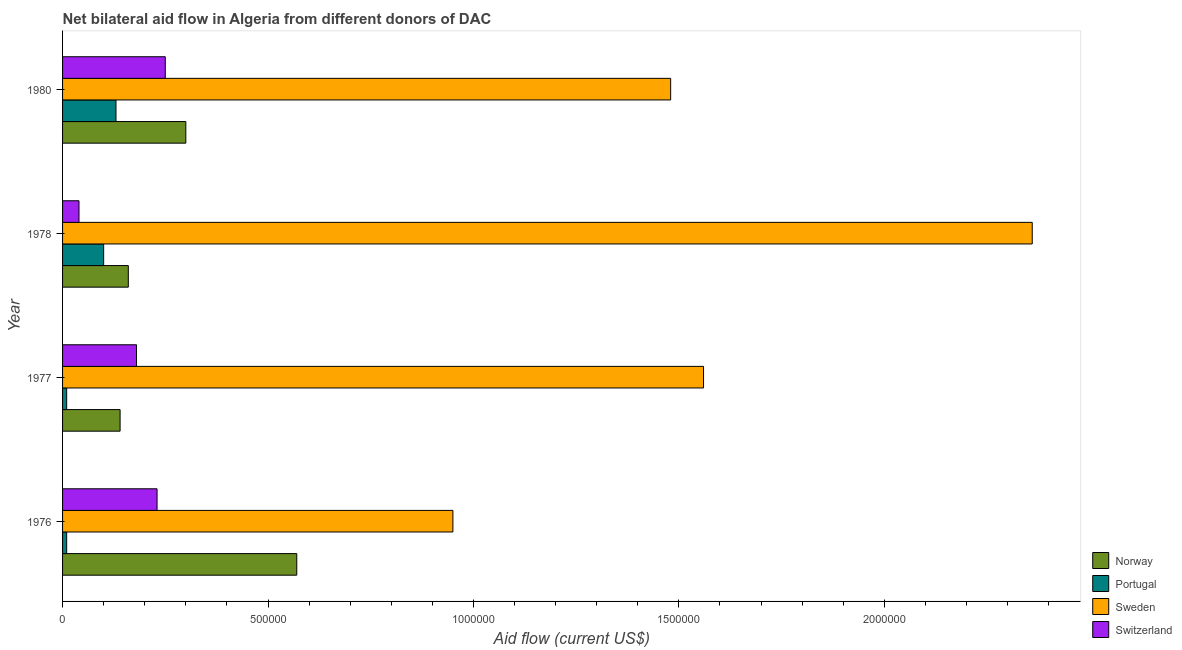How many different coloured bars are there?
Your response must be concise. 4. How many groups of bars are there?
Provide a succinct answer. 4. Are the number of bars on each tick of the Y-axis equal?
Offer a terse response. Yes. How many bars are there on the 4th tick from the bottom?
Ensure brevity in your answer.  4. What is the label of the 1st group of bars from the top?
Your response must be concise. 1980. What is the amount of aid given by norway in 1978?
Keep it short and to the point. 1.60e+05. Across all years, what is the maximum amount of aid given by portugal?
Provide a short and direct response. 1.30e+05. Across all years, what is the minimum amount of aid given by portugal?
Your response must be concise. 10000. In which year was the amount of aid given by switzerland maximum?
Your answer should be very brief. 1980. In which year was the amount of aid given by portugal minimum?
Ensure brevity in your answer.  1976. What is the total amount of aid given by portugal in the graph?
Your answer should be very brief. 2.50e+05. What is the difference between the amount of aid given by sweden in 1976 and that in 1980?
Offer a very short reply. -5.30e+05. What is the difference between the amount of aid given by switzerland in 1977 and the amount of aid given by sweden in 1976?
Your response must be concise. -7.70e+05. What is the average amount of aid given by sweden per year?
Provide a short and direct response. 1.59e+06. In the year 1978, what is the difference between the amount of aid given by sweden and amount of aid given by switzerland?
Your answer should be compact. 2.32e+06. In how many years, is the amount of aid given by norway greater than 1200000 US$?
Provide a succinct answer. 0. What is the ratio of the amount of aid given by portugal in 1976 to that in 1977?
Your answer should be very brief. 1. Is the difference between the amount of aid given by switzerland in 1976 and 1980 greater than the difference between the amount of aid given by sweden in 1976 and 1980?
Your answer should be compact. Yes. What is the difference between the highest and the second highest amount of aid given by norway?
Provide a short and direct response. 2.70e+05. What is the difference between the highest and the lowest amount of aid given by switzerland?
Ensure brevity in your answer.  2.10e+05. What does the 4th bar from the top in 1980 represents?
Give a very brief answer. Norway. What does the 2nd bar from the bottom in 1977 represents?
Offer a terse response. Portugal. How many years are there in the graph?
Make the answer very short. 4. Does the graph contain any zero values?
Provide a succinct answer. No. Does the graph contain grids?
Give a very brief answer. No. How many legend labels are there?
Give a very brief answer. 4. How are the legend labels stacked?
Your response must be concise. Vertical. What is the title of the graph?
Your response must be concise. Net bilateral aid flow in Algeria from different donors of DAC. Does "Social Insurance" appear as one of the legend labels in the graph?
Provide a short and direct response. No. What is the Aid flow (current US$) in Norway in 1976?
Provide a short and direct response. 5.70e+05. What is the Aid flow (current US$) in Sweden in 1976?
Your answer should be very brief. 9.50e+05. What is the Aid flow (current US$) in Switzerland in 1976?
Keep it short and to the point. 2.30e+05. What is the Aid flow (current US$) of Norway in 1977?
Keep it short and to the point. 1.40e+05. What is the Aid flow (current US$) of Portugal in 1977?
Provide a short and direct response. 10000. What is the Aid flow (current US$) of Sweden in 1977?
Keep it short and to the point. 1.56e+06. What is the Aid flow (current US$) in Switzerland in 1977?
Your answer should be very brief. 1.80e+05. What is the Aid flow (current US$) in Portugal in 1978?
Ensure brevity in your answer.  1.00e+05. What is the Aid flow (current US$) of Sweden in 1978?
Offer a very short reply. 2.36e+06. What is the Aid flow (current US$) in Switzerland in 1978?
Provide a succinct answer. 4.00e+04. What is the Aid flow (current US$) of Sweden in 1980?
Offer a terse response. 1.48e+06. What is the Aid flow (current US$) of Switzerland in 1980?
Keep it short and to the point. 2.50e+05. Across all years, what is the maximum Aid flow (current US$) in Norway?
Provide a succinct answer. 5.70e+05. Across all years, what is the maximum Aid flow (current US$) in Portugal?
Offer a very short reply. 1.30e+05. Across all years, what is the maximum Aid flow (current US$) of Sweden?
Keep it short and to the point. 2.36e+06. Across all years, what is the maximum Aid flow (current US$) of Switzerland?
Your answer should be compact. 2.50e+05. Across all years, what is the minimum Aid flow (current US$) in Norway?
Provide a short and direct response. 1.40e+05. Across all years, what is the minimum Aid flow (current US$) of Sweden?
Give a very brief answer. 9.50e+05. What is the total Aid flow (current US$) of Norway in the graph?
Provide a short and direct response. 1.17e+06. What is the total Aid flow (current US$) of Portugal in the graph?
Keep it short and to the point. 2.50e+05. What is the total Aid flow (current US$) in Sweden in the graph?
Give a very brief answer. 6.35e+06. What is the total Aid flow (current US$) of Switzerland in the graph?
Keep it short and to the point. 7.00e+05. What is the difference between the Aid flow (current US$) of Portugal in 1976 and that in 1977?
Offer a very short reply. 0. What is the difference between the Aid flow (current US$) of Sweden in 1976 and that in 1977?
Your response must be concise. -6.10e+05. What is the difference between the Aid flow (current US$) of Switzerland in 1976 and that in 1977?
Ensure brevity in your answer.  5.00e+04. What is the difference between the Aid flow (current US$) in Portugal in 1976 and that in 1978?
Make the answer very short. -9.00e+04. What is the difference between the Aid flow (current US$) of Sweden in 1976 and that in 1978?
Offer a terse response. -1.41e+06. What is the difference between the Aid flow (current US$) of Norway in 1976 and that in 1980?
Provide a short and direct response. 2.70e+05. What is the difference between the Aid flow (current US$) of Portugal in 1976 and that in 1980?
Your response must be concise. -1.20e+05. What is the difference between the Aid flow (current US$) in Sweden in 1976 and that in 1980?
Offer a very short reply. -5.30e+05. What is the difference between the Aid flow (current US$) in Norway in 1977 and that in 1978?
Provide a succinct answer. -2.00e+04. What is the difference between the Aid flow (current US$) of Portugal in 1977 and that in 1978?
Give a very brief answer. -9.00e+04. What is the difference between the Aid flow (current US$) of Sweden in 1977 and that in 1978?
Your answer should be very brief. -8.00e+05. What is the difference between the Aid flow (current US$) of Switzerland in 1977 and that in 1978?
Give a very brief answer. 1.40e+05. What is the difference between the Aid flow (current US$) of Norway in 1977 and that in 1980?
Make the answer very short. -1.60e+05. What is the difference between the Aid flow (current US$) in Switzerland in 1977 and that in 1980?
Offer a very short reply. -7.00e+04. What is the difference between the Aid flow (current US$) of Norway in 1978 and that in 1980?
Offer a very short reply. -1.40e+05. What is the difference between the Aid flow (current US$) of Sweden in 1978 and that in 1980?
Provide a succinct answer. 8.80e+05. What is the difference between the Aid flow (current US$) in Norway in 1976 and the Aid flow (current US$) in Portugal in 1977?
Keep it short and to the point. 5.60e+05. What is the difference between the Aid flow (current US$) in Norway in 1976 and the Aid flow (current US$) in Sweden in 1977?
Ensure brevity in your answer.  -9.90e+05. What is the difference between the Aid flow (current US$) of Norway in 1976 and the Aid flow (current US$) of Switzerland in 1977?
Give a very brief answer. 3.90e+05. What is the difference between the Aid flow (current US$) of Portugal in 1976 and the Aid flow (current US$) of Sweden in 1977?
Offer a terse response. -1.55e+06. What is the difference between the Aid flow (current US$) of Portugal in 1976 and the Aid flow (current US$) of Switzerland in 1977?
Ensure brevity in your answer.  -1.70e+05. What is the difference between the Aid flow (current US$) in Sweden in 1976 and the Aid flow (current US$) in Switzerland in 1977?
Provide a short and direct response. 7.70e+05. What is the difference between the Aid flow (current US$) of Norway in 1976 and the Aid flow (current US$) of Sweden in 1978?
Keep it short and to the point. -1.79e+06. What is the difference between the Aid flow (current US$) in Norway in 1976 and the Aid flow (current US$) in Switzerland in 1978?
Provide a short and direct response. 5.30e+05. What is the difference between the Aid flow (current US$) in Portugal in 1976 and the Aid flow (current US$) in Sweden in 1978?
Your response must be concise. -2.35e+06. What is the difference between the Aid flow (current US$) of Portugal in 1976 and the Aid flow (current US$) of Switzerland in 1978?
Ensure brevity in your answer.  -3.00e+04. What is the difference between the Aid flow (current US$) in Sweden in 1976 and the Aid flow (current US$) in Switzerland in 1978?
Provide a short and direct response. 9.10e+05. What is the difference between the Aid flow (current US$) in Norway in 1976 and the Aid flow (current US$) in Portugal in 1980?
Provide a succinct answer. 4.40e+05. What is the difference between the Aid flow (current US$) in Norway in 1976 and the Aid flow (current US$) in Sweden in 1980?
Your response must be concise. -9.10e+05. What is the difference between the Aid flow (current US$) of Portugal in 1976 and the Aid flow (current US$) of Sweden in 1980?
Offer a very short reply. -1.47e+06. What is the difference between the Aid flow (current US$) of Norway in 1977 and the Aid flow (current US$) of Sweden in 1978?
Your answer should be compact. -2.22e+06. What is the difference between the Aid flow (current US$) in Norway in 1977 and the Aid flow (current US$) in Switzerland in 1978?
Your answer should be compact. 1.00e+05. What is the difference between the Aid flow (current US$) in Portugal in 1977 and the Aid flow (current US$) in Sweden in 1978?
Give a very brief answer. -2.35e+06. What is the difference between the Aid flow (current US$) of Sweden in 1977 and the Aid flow (current US$) of Switzerland in 1978?
Make the answer very short. 1.52e+06. What is the difference between the Aid flow (current US$) of Norway in 1977 and the Aid flow (current US$) of Sweden in 1980?
Your answer should be very brief. -1.34e+06. What is the difference between the Aid flow (current US$) of Portugal in 1977 and the Aid flow (current US$) of Sweden in 1980?
Give a very brief answer. -1.47e+06. What is the difference between the Aid flow (current US$) of Portugal in 1977 and the Aid flow (current US$) of Switzerland in 1980?
Offer a terse response. -2.40e+05. What is the difference between the Aid flow (current US$) in Sweden in 1977 and the Aid flow (current US$) in Switzerland in 1980?
Provide a short and direct response. 1.31e+06. What is the difference between the Aid flow (current US$) in Norway in 1978 and the Aid flow (current US$) in Portugal in 1980?
Your answer should be very brief. 3.00e+04. What is the difference between the Aid flow (current US$) in Norway in 1978 and the Aid flow (current US$) in Sweden in 1980?
Offer a very short reply. -1.32e+06. What is the difference between the Aid flow (current US$) of Portugal in 1978 and the Aid flow (current US$) of Sweden in 1980?
Your answer should be compact. -1.38e+06. What is the difference between the Aid flow (current US$) of Portugal in 1978 and the Aid flow (current US$) of Switzerland in 1980?
Your response must be concise. -1.50e+05. What is the difference between the Aid flow (current US$) of Sweden in 1978 and the Aid flow (current US$) of Switzerland in 1980?
Your answer should be very brief. 2.11e+06. What is the average Aid flow (current US$) in Norway per year?
Your answer should be compact. 2.92e+05. What is the average Aid flow (current US$) of Portugal per year?
Provide a succinct answer. 6.25e+04. What is the average Aid flow (current US$) of Sweden per year?
Your answer should be very brief. 1.59e+06. What is the average Aid flow (current US$) in Switzerland per year?
Give a very brief answer. 1.75e+05. In the year 1976, what is the difference between the Aid flow (current US$) in Norway and Aid flow (current US$) in Portugal?
Ensure brevity in your answer.  5.60e+05. In the year 1976, what is the difference between the Aid flow (current US$) in Norway and Aid flow (current US$) in Sweden?
Offer a very short reply. -3.80e+05. In the year 1976, what is the difference between the Aid flow (current US$) of Portugal and Aid flow (current US$) of Sweden?
Your response must be concise. -9.40e+05. In the year 1976, what is the difference between the Aid flow (current US$) of Portugal and Aid flow (current US$) of Switzerland?
Your answer should be very brief. -2.20e+05. In the year 1976, what is the difference between the Aid flow (current US$) in Sweden and Aid flow (current US$) in Switzerland?
Your response must be concise. 7.20e+05. In the year 1977, what is the difference between the Aid flow (current US$) of Norway and Aid flow (current US$) of Portugal?
Ensure brevity in your answer.  1.30e+05. In the year 1977, what is the difference between the Aid flow (current US$) of Norway and Aid flow (current US$) of Sweden?
Provide a succinct answer. -1.42e+06. In the year 1977, what is the difference between the Aid flow (current US$) in Norway and Aid flow (current US$) in Switzerland?
Give a very brief answer. -4.00e+04. In the year 1977, what is the difference between the Aid flow (current US$) of Portugal and Aid flow (current US$) of Sweden?
Provide a succinct answer. -1.55e+06. In the year 1977, what is the difference between the Aid flow (current US$) of Portugal and Aid flow (current US$) of Switzerland?
Provide a short and direct response. -1.70e+05. In the year 1977, what is the difference between the Aid flow (current US$) of Sweden and Aid flow (current US$) of Switzerland?
Your answer should be very brief. 1.38e+06. In the year 1978, what is the difference between the Aid flow (current US$) in Norway and Aid flow (current US$) in Portugal?
Your answer should be compact. 6.00e+04. In the year 1978, what is the difference between the Aid flow (current US$) in Norway and Aid flow (current US$) in Sweden?
Make the answer very short. -2.20e+06. In the year 1978, what is the difference between the Aid flow (current US$) in Portugal and Aid flow (current US$) in Sweden?
Ensure brevity in your answer.  -2.26e+06. In the year 1978, what is the difference between the Aid flow (current US$) of Sweden and Aid flow (current US$) of Switzerland?
Ensure brevity in your answer.  2.32e+06. In the year 1980, what is the difference between the Aid flow (current US$) of Norway and Aid flow (current US$) of Sweden?
Provide a short and direct response. -1.18e+06. In the year 1980, what is the difference between the Aid flow (current US$) of Norway and Aid flow (current US$) of Switzerland?
Provide a short and direct response. 5.00e+04. In the year 1980, what is the difference between the Aid flow (current US$) of Portugal and Aid flow (current US$) of Sweden?
Offer a very short reply. -1.35e+06. In the year 1980, what is the difference between the Aid flow (current US$) of Sweden and Aid flow (current US$) of Switzerland?
Make the answer very short. 1.23e+06. What is the ratio of the Aid flow (current US$) in Norway in 1976 to that in 1977?
Your response must be concise. 4.07. What is the ratio of the Aid flow (current US$) in Portugal in 1976 to that in 1977?
Offer a very short reply. 1. What is the ratio of the Aid flow (current US$) in Sweden in 1976 to that in 1977?
Make the answer very short. 0.61. What is the ratio of the Aid flow (current US$) in Switzerland in 1976 to that in 1977?
Give a very brief answer. 1.28. What is the ratio of the Aid flow (current US$) of Norway in 1976 to that in 1978?
Offer a terse response. 3.56. What is the ratio of the Aid flow (current US$) in Portugal in 1976 to that in 1978?
Provide a succinct answer. 0.1. What is the ratio of the Aid flow (current US$) in Sweden in 1976 to that in 1978?
Your answer should be very brief. 0.4. What is the ratio of the Aid flow (current US$) of Switzerland in 1976 to that in 1978?
Offer a terse response. 5.75. What is the ratio of the Aid flow (current US$) of Norway in 1976 to that in 1980?
Offer a very short reply. 1.9. What is the ratio of the Aid flow (current US$) of Portugal in 1976 to that in 1980?
Provide a succinct answer. 0.08. What is the ratio of the Aid flow (current US$) of Sweden in 1976 to that in 1980?
Make the answer very short. 0.64. What is the ratio of the Aid flow (current US$) of Switzerland in 1976 to that in 1980?
Make the answer very short. 0.92. What is the ratio of the Aid flow (current US$) in Norway in 1977 to that in 1978?
Give a very brief answer. 0.88. What is the ratio of the Aid flow (current US$) in Sweden in 1977 to that in 1978?
Provide a succinct answer. 0.66. What is the ratio of the Aid flow (current US$) in Norway in 1977 to that in 1980?
Your answer should be compact. 0.47. What is the ratio of the Aid flow (current US$) in Portugal in 1977 to that in 1980?
Offer a terse response. 0.08. What is the ratio of the Aid flow (current US$) of Sweden in 1977 to that in 1980?
Provide a short and direct response. 1.05. What is the ratio of the Aid flow (current US$) of Switzerland in 1977 to that in 1980?
Your answer should be very brief. 0.72. What is the ratio of the Aid flow (current US$) in Norway in 1978 to that in 1980?
Your answer should be very brief. 0.53. What is the ratio of the Aid flow (current US$) of Portugal in 1978 to that in 1980?
Your answer should be very brief. 0.77. What is the ratio of the Aid flow (current US$) of Sweden in 1978 to that in 1980?
Provide a short and direct response. 1.59. What is the ratio of the Aid flow (current US$) in Switzerland in 1978 to that in 1980?
Offer a very short reply. 0.16. What is the difference between the highest and the second highest Aid flow (current US$) of Norway?
Provide a short and direct response. 2.70e+05. What is the difference between the highest and the second highest Aid flow (current US$) in Portugal?
Your answer should be compact. 3.00e+04. What is the difference between the highest and the lowest Aid flow (current US$) in Norway?
Provide a succinct answer. 4.30e+05. What is the difference between the highest and the lowest Aid flow (current US$) in Portugal?
Keep it short and to the point. 1.20e+05. What is the difference between the highest and the lowest Aid flow (current US$) of Sweden?
Give a very brief answer. 1.41e+06. 